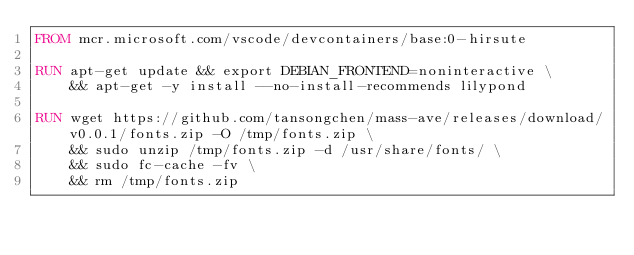<code> <loc_0><loc_0><loc_500><loc_500><_Dockerfile_>FROM mcr.microsoft.com/vscode/devcontainers/base:0-hirsute

RUN apt-get update && export DEBIAN_FRONTEND=noninteractive \
    && apt-get -y install --no-install-recommends lilypond

RUN wget https://github.com/tansongchen/mass-ave/releases/download/v0.0.1/fonts.zip -O /tmp/fonts.zip \
    && sudo unzip /tmp/fonts.zip -d /usr/share/fonts/ \
    && sudo fc-cache -fv \
    && rm /tmp/fonts.zip
</code> 